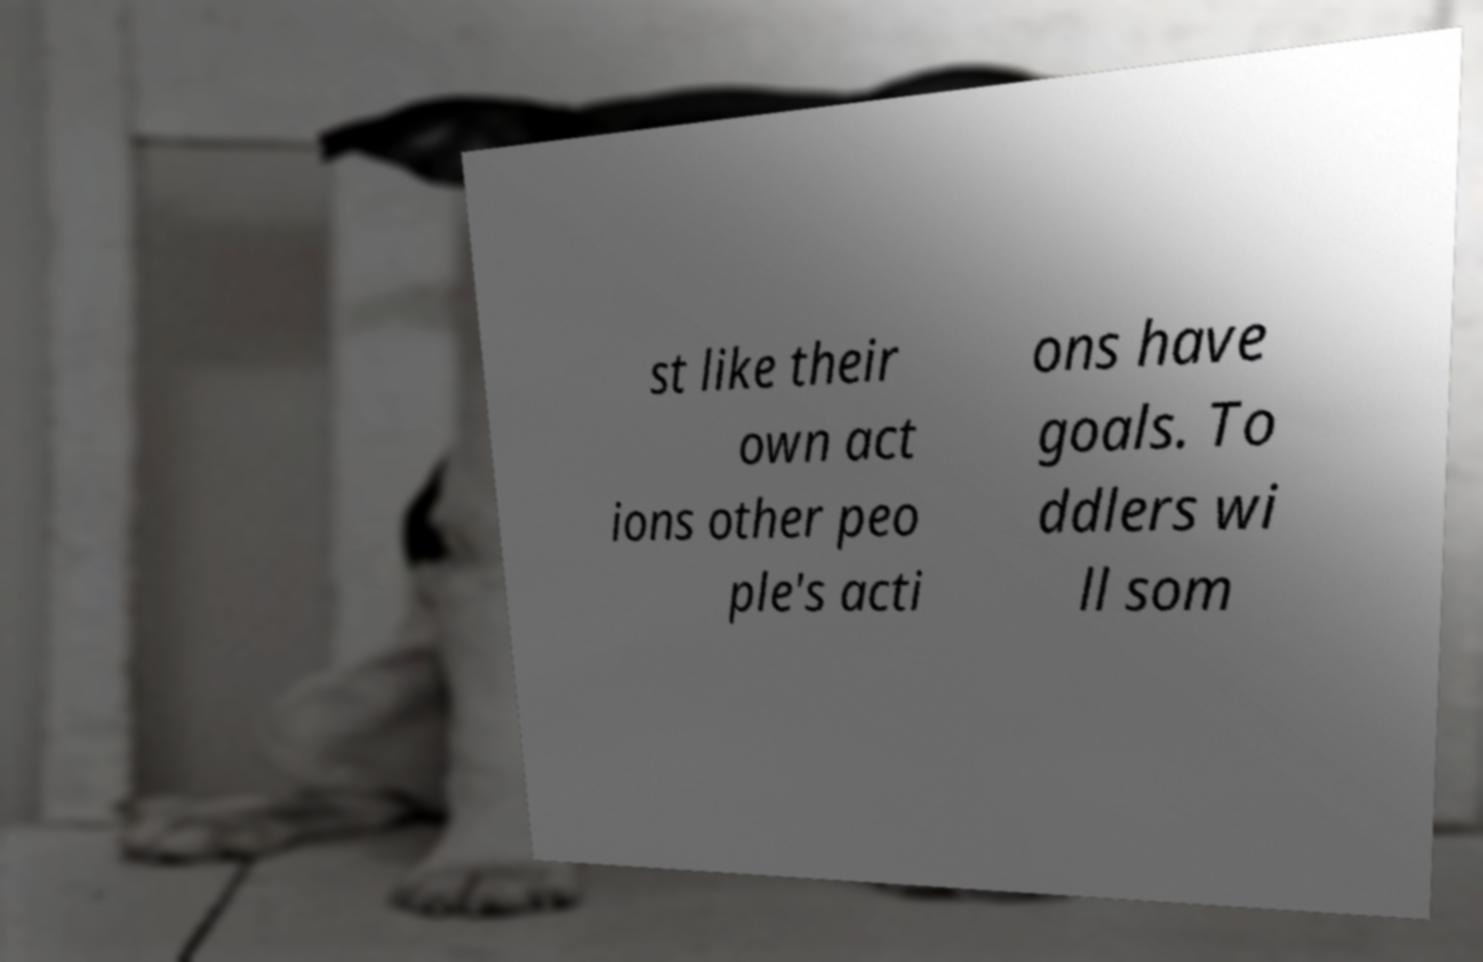Could you assist in decoding the text presented in this image and type it out clearly? st like their own act ions other peo ple's acti ons have goals. To ddlers wi ll som 